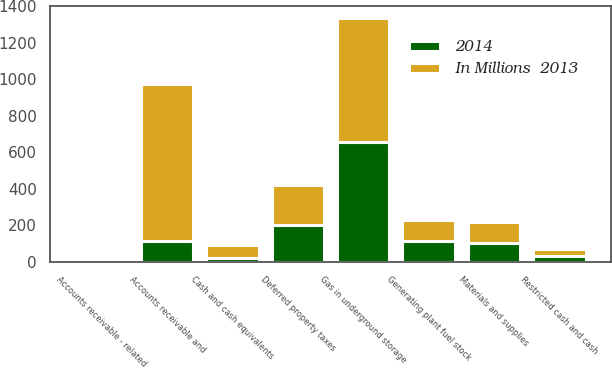Convert chart. <chart><loc_0><loc_0><loc_500><loc_500><stacked_bar_chart><ecel><fcel>Cash and cash equivalents<fcel>Restricted cash and cash<fcel>Accounts receivable and<fcel>Accounts receivable - related<fcel>Gas in underground storage<fcel>Materials and supplies<fcel>Generating plant fuel stock<fcel>Deferred property taxes<nl><fcel>In Millions  2013<fcel>71<fcel>37<fcel>863<fcel>1<fcel>681<fcel>113<fcel>112<fcel>216<nl><fcel>2014<fcel>18<fcel>31<fcel>112<fcel>4<fcel>653<fcel>103<fcel>113<fcel>202<nl></chart> 